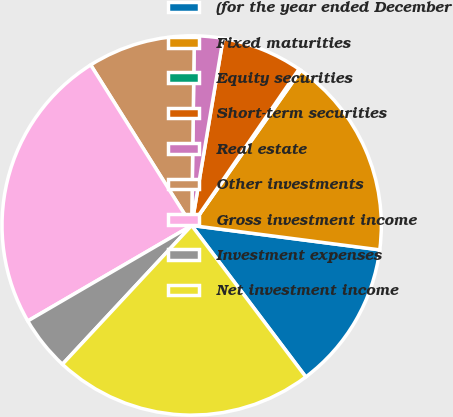Convert chart to OTSL. <chart><loc_0><loc_0><loc_500><loc_500><pie_chart><fcel>(for the year ended December<fcel>Fixed maturities<fcel>Equity securities<fcel>Short-term securities<fcel>Real estate<fcel>Other investments<fcel>Gross investment income<fcel>Investment expenses<fcel>Net investment income<nl><fcel>12.67%<fcel>17.29%<fcel>0.19%<fcel>6.92%<fcel>2.43%<fcel>9.16%<fcel>24.46%<fcel>4.67%<fcel>22.21%<nl></chart> 